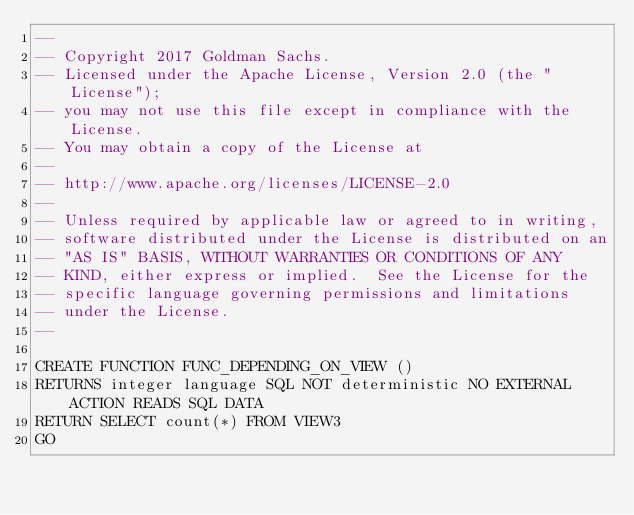<code> <loc_0><loc_0><loc_500><loc_500><_SQL_>--
-- Copyright 2017 Goldman Sachs.
-- Licensed under the Apache License, Version 2.0 (the "License");
-- you may not use this file except in compliance with the License.
-- You may obtain a copy of the License at
--
-- http://www.apache.org/licenses/LICENSE-2.0
--
-- Unless required by applicable law or agreed to in writing,
-- software distributed under the License is distributed on an
-- "AS IS" BASIS, WITHOUT WARRANTIES OR CONDITIONS OF ANY
-- KIND, either express or implied.  See the License for the
-- specific language governing permissions and limitations
-- under the License.
--

CREATE FUNCTION FUNC_DEPENDING_ON_VIEW ()
RETURNS integer language SQL NOT deterministic NO EXTERNAL ACTION READS SQL DATA
RETURN SELECT count(*) FROM VIEW3
GO
</code> 